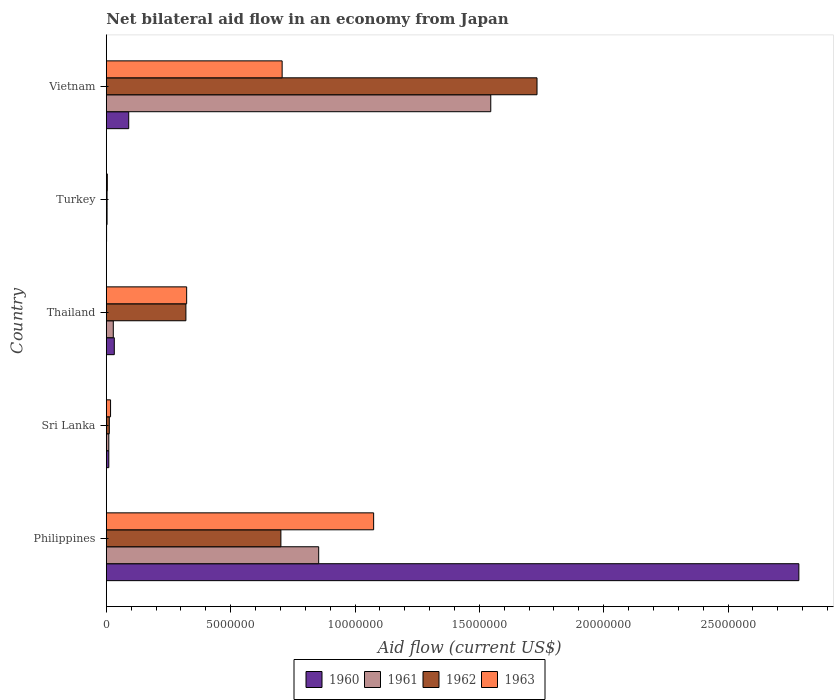How many different coloured bars are there?
Provide a succinct answer. 4. Are the number of bars per tick equal to the number of legend labels?
Your answer should be compact. Yes. Are the number of bars on each tick of the Y-axis equal?
Your response must be concise. Yes. How many bars are there on the 3rd tick from the top?
Ensure brevity in your answer.  4. How many bars are there on the 2nd tick from the bottom?
Make the answer very short. 4. What is the label of the 1st group of bars from the top?
Ensure brevity in your answer.  Vietnam. What is the net bilateral aid flow in 1963 in Turkey?
Make the answer very short. 4.00e+04. Across all countries, what is the maximum net bilateral aid flow in 1960?
Your response must be concise. 2.78e+07. What is the total net bilateral aid flow in 1963 in the graph?
Provide a short and direct response. 2.13e+07. What is the difference between the net bilateral aid flow in 1960 in Philippines and that in Thailand?
Offer a terse response. 2.75e+07. What is the difference between the net bilateral aid flow in 1963 in Vietnam and the net bilateral aid flow in 1960 in Philippines?
Offer a terse response. -2.08e+07. What is the average net bilateral aid flow in 1961 per country?
Provide a short and direct response. 4.88e+06. In how many countries, is the net bilateral aid flow in 1961 greater than 20000000 US$?
Make the answer very short. 0. What is the ratio of the net bilateral aid flow in 1960 in Philippines to that in Vietnam?
Ensure brevity in your answer.  30.94. Is the net bilateral aid flow in 1961 in Philippines less than that in Vietnam?
Your response must be concise. Yes. What is the difference between the highest and the second highest net bilateral aid flow in 1962?
Offer a terse response. 1.03e+07. What is the difference between the highest and the lowest net bilateral aid flow in 1961?
Your answer should be very brief. 1.54e+07. In how many countries, is the net bilateral aid flow in 1962 greater than the average net bilateral aid flow in 1962 taken over all countries?
Make the answer very short. 2. Is the sum of the net bilateral aid flow in 1962 in Thailand and Turkey greater than the maximum net bilateral aid flow in 1963 across all countries?
Give a very brief answer. No. Is it the case that in every country, the sum of the net bilateral aid flow in 1963 and net bilateral aid flow in 1960 is greater than the sum of net bilateral aid flow in 1962 and net bilateral aid flow in 1961?
Your answer should be compact. No. What does the 2nd bar from the top in Philippines represents?
Provide a succinct answer. 1962. Is it the case that in every country, the sum of the net bilateral aid flow in 1963 and net bilateral aid flow in 1961 is greater than the net bilateral aid flow in 1960?
Your response must be concise. No. How many bars are there?
Ensure brevity in your answer.  20. What is the difference between two consecutive major ticks on the X-axis?
Offer a terse response. 5.00e+06. Does the graph contain grids?
Your answer should be very brief. No. Where does the legend appear in the graph?
Ensure brevity in your answer.  Bottom center. What is the title of the graph?
Ensure brevity in your answer.  Net bilateral aid flow in an economy from Japan. Does "2007" appear as one of the legend labels in the graph?
Provide a short and direct response. No. What is the label or title of the X-axis?
Your response must be concise. Aid flow (current US$). What is the Aid flow (current US$) in 1960 in Philippines?
Offer a terse response. 2.78e+07. What is the Aid flow (current US$) of 1961 in Philippines?
Make the answer very short. 8.54e+06. What is the Aid flow (current US$) of 1962 in Philippines?
Offer a very short reply. 7.02e+06. What is the Aid flow (current US$) in 1963 in Philippines?
Give a very brief answer. 1.08e+07. What is the Aid flow (current US$) of 1961 in Sri Lanka?
Provide a short and direct response. 1.00e+05. What is the Aid flow (current US$) of 1962 in Sri Lanka?
Provide a short and direct response. 1.20e+05. What is the Aid flow (current US$) of 1963 in Sri Lanka?
Make the answer very short. 1.70e+05. What is the Aid flow (current US$) in 1962 in Thailand?
Your answer should be compact. 3.20e+06. What is the Aid flow (current US$) in 1963 in Thailand?
Provide a succinct answer. 3.23e+06. What is the Aid flow (current US$) in 1962 in Turkey?
Your answer should be compact. 3.00e+04. What is the Aid flow (current US$) of 1960 in Vietnam?
Provide a succinct answer. 9.00e+05. What is the Aid flow (current US$) of 1961 in Vietnam?
Ensure brevity in your answer.  1.55e+07. What is the Aid flow (current US$) of 1962 in Vietnam?
Your response must be concise. 1.73e+07. What is the Aid flow (current US$) of 1963 in Vietnam?
Offer a very short reply. 7.07e+06. Across all countries, what is the maximum Aid flow (current US$) of 1960?
Ensure brevity in your answer.  2.78e+07. Across all countries, what is the maximum Aid flow (current US$) in 1961?
Offer a terse response. 1.55e+07. Across all countries, what is the maximum Aid flow (current US$) in 1962?
Give a very brief answer. 1.73e+07. Across all countries, what is the maximum Aid flow (current US$) of 1963?
Offer a very short reply. 1.08e+07. Across all countries, what is the minimum Aid flow (current US$) of 1960?
Your response must be concise. 10000. Across all countries, what is the minimum Aid flow (current US$) in 1961?
Keep it short and to the point. 3.00e+04. Across all countries, what is the minimum Aid flow (current US$) of 1962?
Offer a terse response. 3.00e+04. Across all countries, what is the minimum Aid flow (current US$) in 1963?
Provide a short and direct response. 4.00e+04. What is the total Aid flow (current US$) in 1960 in the graph?
Make the answer very short. 2.92e+07. What is the total Aid flow (current US$) of 1961 in the graph?
Offer a very short reply. 2.44e+07. What is the total Aid flow (current US$) of 1962 in the graph?
Your answer should be compact. 2.77e+07. What is the total Aid flow (current US$) of 1963 in the graph?
Ensure brevity in your answer.  2.13e+07. What is the difference between the Aid flow (current US$) in 1960 in Philippines and that in Sri Lanka?
Your answer should be very brief. 2.78e+07. What is the difference between the Aid flow (current US$) in 1961 in Philippines and that in Sri Lanka?
Ensure brevity in your answer.  8.44e+06. What is the difference between the Aid flow (current US$) of 1962 in Philippines and that in Sri Lanka?
Keep it short and to the point. 6.90e+06. What is the difference between the Aid flow (current US$) of 1963 in Philippines and that in Sri Lanka?
Keep it short and to the point. 1.06e+07. What is the difference between the Aid flow (current US$) of 1960 in Philippines and that in Thailand?
Keep it short and to the point. 2.75e+07. What is the difference between the Aid flow (current US$) of 1961 in Philippines and that in Thailand?
Your answer should be compact. 8.26e+06. What is the difference between the Aid flow (current US$) of 1962 in Philippines and that in Thailand?
Keep it short and to the point. 3.82e+06. What is the difference between the Aid flow (current US$) of 1963 in Philippines and that in Thailand?
Offer a very short reply. 7.52e+06. What is the difference between the Aid flow (current US$) in 1960 in Philippines and that in Turkey?
Your answer should be compact. 2.78e+07. What is the difference between the Aid flow (current US$) of 1961 in Philippines and that in Turkey?
Your answer should be very brief. 8.51e+06. What is the difference between the Aid flow (current US$) in 1962 in Philippines and that in Turkey?
Offer a terse response. 6.99e+06. What is the difference between the Aid flow (current US$) of 1963 in Philippines and that in Turkey?
Give a very brief answer. 1.07e+07. What is the difference between the Aid flow (current US$) in 1960 in Philippines and that in Vietnam?
Provide a succinct answer. 2.70e+07. What is the difference between the Aid flow (current US$) of 1961 in Philippines and that in Vietnam?
Keep it short and to the point. -6.92e+06. What is the difference between the Aid flow (current US$) in 1962 in Philippines and that in Vietnam?
Make the answer very short. -1.03e+07. What is the difference between the Aid flow (current US$) of 1963 in Philippines and that in Vietnam?
Provide a short and direct response. 3.68e+06. What is the difference between the Aid flow (current US$) of 1961 in Sri Lanka and that in Thailand?
Your answer should be compact. -1.80e+05. What is the difference between the Aid flow (current US$) of 1962 in Sri Lanka and that in Thailand?
Offer a terse response. -3.08e+06. What is the difference between the Aid flow (current US$) in 1963 in Sri Lanka and that in Thailand?
Offer a very short reply. -3.06e+06. What is the difference between the Aid flow (current US$) in 1960 in Sri Lanka and that in Turkey?
Your answer should be compact. 9.00e+04. What is the difference between the Aid flow (current US$) of 1961 in Sri Lanka and that in Turkey?
Keep it short and to the point. 7.00e+04. What is the difference between the Aid flow (current US$) of 1962 in Sri Lanka and that in Turkey?
Make the answer very short. 9.00e+04. What is the difference between the Aid flow (current US$) of 1960 in Sri Lanka and that in Vietnam?
Your response must be concise. -8.00e+05. What is the difference between the Aid flow (current US$) of 1961 in Sri Lanka and that in Vietnam?
Your answer should be very brief. -1.54e+07. What is the difference between the Aid flow (current US$) in 1962 in Sri Lanka and that in Vietnam?
Ensure brevity in your answer.  -1.72e+07. What is the difference between the Aid flow (current US$) in 1963 in Sri Lanka and that in Vietnam?
Offer a very short reply. -6.90e+06. What is the difference between the Aid flow (current US$) of 1961 in Thailand and that in Turkey?
Keep it short and to the point. 2.50e+05. What is the difference between the Aid flow (current US$) of 1962 in Thailand and that in Turkey?
Offer a very short reply. 3.17e+06. What is the difference between the Aid flow (current US$) in 1963 in Thailand and that in Turkey?
Provide a short and direct response. 3.19e+06. What is the difference between the Aid flow (current US$) of 1960 in Thailand and that in Vietnam?
Offer a very short reply. -5.80e+05. What is the difference between the Aid flow (current US$) in 1961 in Thailand and that in Vietnam?
Your response must be concise. -1.52e+07. What is the difference between the Aid flow (current US$) in 1962 in Thailand and that in Vietnam?
Make the answer very short. -1.41e+07. What is the difference between the Aid flow (current US$) of 1963 in Thailand and that in Vietnam?
Your response must be concise. -3.84e+06. What is the difference between the Aid flow (current US$) in 1960 in Turkey and that in Vietnam?
Your answer should be compact. -8.90e+05. What is the difference between the Aid flow (current US$) in 1961 in Turkey and that in Vietnam?
Your answer should be compact. -1.54e+07. What is the difference between the Aid flow (current US$) of 1962 in Turkey and that in Vietnam?
Your answer should be very brief. -1.73e+07. What is the difference between the Aid flow (current US$) in 1963 in Turkey and that in Vietnam?
Offer a very short reply. -7.03e+06. What is the difference between the Aid flow (current US$) in 1960 in Philippines and the Aid flow (current US$) in 1961 in Sri Lanka?
Make the answer very short. 2.78e+07. What is the difference between the Aid flow (current US$) of 1960 in Philippines and the Aid flow (current US$) of 1962 in Sri Lanka?
Ensure brevity in your answer.  2.77e+07. What is the difference between the Aid flow (current US$) in 1960 in Philippines and the Aid flow (current US$) in 1963 in Sri Lanka?
Your answer should be compact. 2.77e+07. What is the difference between the Aid flow (current US$) of 1961 in Philippines and the Aid flow (current US$) of 1962 in Sri Lanka?
Give a very brief answer. 8.42e+06. What is the difference between the Aid flow (current US$) of 1961 in Philippines and the Aid flow (current US$) of 1963 in Sri Lanka?
Offer a very short reply. 8.37e+06. What is the difference between the Aid flow (current US$) of 1962 in Philippines and the Aid flow (current US$) of 1963 in Sri Lanka?
Provide a succinct answer. 6.85e+06. What is the difference between the Aid flow (current US$) of 1960 in Philippines and the Aid flow (current US$) of 1961 in Thailand?
Keep it short and to the point. 2.76e+07. What is the difference between the Aid flow (current US$) in 1960 in Philippines and the Aid flow (current US$) in 1962 in Thailand?
Provide a succinct answer. 2.46e+07. What is the difference between the Aid flow (current US$) of 1960 in Philippines and the Aid flow (current US$) of 1963 in Thailand?
Provide a succinct answer. 2.46e+07. What is the difference between the Aid flow (current US$) in 1961 in Philippines and the Aid flow (current US$) in 1962 in Thailand?
Your response must be concise. 5.34e+06. What is the difference between the Aid flow (current US$) in 1961 in Philippines and the Aid flow (current US$) in 1963 in Thailand?
Ensure brevity in your answer.  5.31e+06. What is the difference between the Aid flow (current US$) of 1962 in Philippines and the Aid flow (current US$) of 1963 in Thailand?
Provide a short and direct response. 3.79e+06. What is the difference between the Aid flow (current US$) in 1960 in Philippines and the Aid flow (current US$) in 1961 in Turkey?
Make the answer very short. 2.78e+07. What is the difference between the Aid flow (current US$) in 1960 in Philippines and the Aid flow (current US$) in 1962 in Turkey?
Offer a terse response. 2.78e+07. What is the difference between the Aid flow (current US$) in 1960 in Philippines and the Aid flow (current US$) in 1963 in Turkey?
Your answer should be very brief. 2.78e+07. What is the difference between the Aid flow (current US$) in 1961 in Philippines and the Aid flow (current US$) in 1962 in Turkey?
Ensure brevity in your answer.  8.51e+06. What is the difference between the Aid flow (current US$) of 1961 in Philippines and the Aid flow (current US$) of 1963 in Turkey?
Offer a very short reply. 8.50e+06. What is the difference between the Aid flow (current US$) in 1962 in Philippines and the Aid flow (current US$) in 1963 in Turkey?
Make the answer very short. 6.98e+06. What is the difference between the Aid flow (current US$) of 1960 in Philippines and the Aid flow (current US$) of 1961 in Vietnam?
Provide a succinct answer. 1.24e+07. What is the difference between the Aid flow (current US$) in 1960 in Philippines and the Aid flow (current US$) in 1962 in Vietnam?
Provide a short and direct response. 1.05e+07. What is the difference between the Aid flow (current US$) in 1960 in Philippines and the Aid flow (current US$) in 1963 in Vietnam?
Make the answer very short. 2.08e+07. What is the difference between the Aid flow (current US$) in 1961 in Philippines and the Aid flow (current US$) in 1962 in Vietnam?
Offer a terse response. -8.78e+06. What is the difference between the Aid flow (current US$) of 1961 in Philippines and the Aid flow (current US$) of 1963 in Vietnam?
Your answer should be very brief. 1.47e+06. What is the difference between the Aid flow (current US$) in 1962 in Philippines and the Aid flow (current US$) in 1963 in Vietnam?
Give a very brief answer. -5.00e+04. What is the difference between the Aid flow (current US$) in 1960 in Sri Lanka and the Aid flow (current US$) in 1961 in Thailand?
Give a very brief answer. -1.80e+05. What is the difference between the Aid flow (current US$) in 1960 in Sri Lanka and the Aid flow (current US$) in 1962 in Thailand?
Offer a terse response. -3.10e+06. What is the difference between the Aid flow (current US$) of 1960 in Sri Lanka and the Aid flow (current US$) of 1963 in Thailand?
Provide a short and direct response. -3.13e+06. What is the difference between the Aid flow (current US$) in 1961 in Sri Lanka and the Aid flow (current US$) in 1962 in Thailand?
Make the answer very short. -3.10e+06. What is the difference between the Aid flow (current US$) in 1961 in Sri Lanka and the Aid flow (current US$) in 1963 in Thailand?
Your response must be concise. -3.13e+06. What is the difference between the Aid flow (current US$) in 1962 in Sri Lanka and the Aid flow (current US$) in 1963 in Thailand?
Offer a terse response. -3.11e+06. What is the difference between the Aid flow (current US$) of 1960 in Sri Lanka and the Aid flow (current US$) of 1961 in Turkey?
Provide a succinct answer. 7.00e+04. What is the difference between the Aid flow (current US$) of 1960 in Sri Lanka and the Aid flow (current US$) of 1962 in Turkey?
Offer a terse response. 7.00e+04. What is the difference between the Aid flow (current US$) of 1960 in Sri Lanka and the Aid flow (current US$) of 1963 in Turkey?
Your answer should be compact. 6.00e+04. What is the difference between the Aid flow (current US$) in 1961 in Sri Lanka and the Aid flow (current US$) in 1962 in Turkey?
Offer a very short reply. 7.00e+04. What is the difference between the Aid flow (current US$) in 1960 in Sri Lanka and the Aid flow (current US$) in 1961 in Vietnam?
Make the answer very short. -1.54e+07. What is the difference between the Aid flow (current US$) in 1960 in Sri Lanka and the Aid flow (current US$) in 1962 in Vietnam?
Offer a terse response. -1.72e+07. What is the difference between the Aid flow (current US$) of 1960 in Sri Lanka and the Aid flow (current US$) of 1963 in Vietnam?
Offer a terse response. -6.97e+06. What is the difference between the Aid flow (current US$) of 1961 in Sri Lanka and the Aid flow (current US$) of 1962 in Vietnam?
Your response must be concise. -1.72e+07. What is the difference between the Aid flow (current US$) of 1961 in Sri Lanka and the Aid flow (current US$) of 1963 in Vietnam?
Provide a succinct answer. -6.97e+06. What is the difference between the Aid flow (current US$) in 1962 in Sri Lanka and the Aid flow (current US$) in 1963 in Vietnam?
Ensure brevity in your answer.  -6.95e+06. What is the difference between the Aid flow (current US$) of 1960 in Thailand and the Aid flow (current US$) of 1961 in Turkey?
Provide a short and direct response. 2.90e+05. What is the difference between the Aid flow (current US$) of 1960 in Thailand and the Aid flow (current US$) of 1963 in Turkey?
Offer a very short reply. 2.80e+05. What is the difference between the Aid flow (current US$) in 1961 in Thailand and the Aid flow (current US$) in 1962 in Turkey?
Offer a terse response. 2.50e+05. What is the difference between the Aid flow (current US$) in 1961 in Thailand and the Aid flow (current US$) in 1963 in Turkey?
Your answer should be very brief. 2.40e+05. What is the difference between the Aid flow (current US$) in 1962 in Thailand and the Aid flow (current US$) in 1963 in Turkey?
Offer a very short reply. 3.16e+06. What is the difference between the Aid flow (current US$) of 1960 in Thailand and the Aid flow (current US$) of 1961 in Vietnam?
Your answer should be compact. -1.51e+07. What is the difference between the Aid flow (current US$) in 1960 in Thailand and the Aid flow (current US$) in 1962 in Vietnam?
Keep it short and to the point. -1.70e+07. What is the difference between the Aid flow (current US$) in 1960 in Thailand and the Aid flow (current US$) in 1963 in Vietnam?
Offer a terse response. -6.75e+06. What is the difference between the Aid flow (current US$) in 1961 in Thailand and the Aid flow (current US$) in 1962 in Vietnam?
Your answer should be compact. -1.70e+07. What is the difference between the Aid flow (current US$) in 1961 in Thailand and the Aid flow (current US$) in 1963 in Vietnam?
Offer a terse response. -6.79e+06. What is the difference between the Aid flow (current US$) in 1962 in Thailand and the Aid flow (current US$) in 1963 in Vietnam?
Offer a terse response. -3.87e+06. What is the difference between the Aid flow (current US$) in 1960 in Turkey and the Aid flow (current US$) in 1961 in Vietnam?
Your answer should be very brief. -1.54e+07. What is the difference between the Aid flow (current US$) in 1960 in Turkey and the Aid flow (current US$) in 1962 in Vietnam?
Provide a succinct answer. -1.73e+07. What is the difference between the Aid flow (current US$) in 1960 in Turkey and the Aid flow (current US$) in 1963 in Vietnam?
Offer a terse response. -7.06e+06. What is the difference between the Aid flow (current US$) in 1961 in Turkey and the Aid flow (current US$) in 1962 in Vietnam?
Ensure brevity in your answer.  -1.73e+07. What is the difference between the Aid flow (current US$) of 1961 in Turkey and the Aid flow (current US$) of 1963 in Vietnam?
Make the answer very short. -7.04e+06. What is the difference between the Aid flow (current US$) in 1962 in Turkey and the Aid flow (current US$) in 1963 in Vietnam?
Offer a terse response. -7.04e+06. What is the average Aid flow (current US$) in 1960 per country?
Offer a very short reply. 5.84e+06. What is the average Aid flow (current US$) of 1961 per country?
Provide a short and direct response. 4.88e+06. What is the average Aid flow (current US$) of 1962 per country?
Make the answer very short. 5.54e+06. What is the average Aid flow (current US$) in 1963 per country?
Give a very brief answer. 4.25e+06. What is the difference between the Aid flow (current US$) of 1960 and Aid flow (current US$) of 1961 in Philippines?
Offer a terse response. 1.93e+07. What is the difference between the Aid flow (current US$) of 1960 and Aid flow (current US$) of 1962 in Philippines?
Your response must be concise. 2.08e+07. What is the difference between the Aid flow (current US$) in 1960 and Aid flow (current US$) in 1963 in Philippines?
Give a very brief answer. 1.71e+07. What is the difference between the Aid flow (current US$) of 1961 and Aid flow (current US$) of 1962 in Philippines?
Keep it short and to the point. 1.52e+06. What is the difference between the Aid flow (current US$) in 1961 and Aid flow (current US$) in 1963 in Philippines?
Your answer should be compact. -2.21e+06. What is the difference between the Aid flow (current US$) of 1962 and Aid flow (current US$) of 1963 in Philippines?
Offer a very short reply. -3.73e+06. What is the difference between the Aid flow (current US$) of 1960 and Aid flow (current US$) of 1962 in Sri Lanka?
Ensure brevity in your answer.  -2.00e+04. What is the difference between the Aid flow (current US$) in 1961 and Aid flow (current US$) in 1962 in Sri Lanka?
Ensure brevity in your answer.  -2.00e+04. What is the difference between the Aid flow (current US$) in 1961 and Aid flow (current US$) in 1963 in Sri Lanka?
Offer a terse response. -7.00e+04. What is the difference between the Aid flow (current US$) in 1960 and Aid flow (current US$) in 1961 in Thailand?
Keep it short and to the point. 4.00e+04. What is the difference between the Aid flow (current US$) in 1960 and Aid flow (current US$) in 1962 in Thailand?
Ensure brevity in your answer.  -2.88e+06. What is the difference between the Aid flow (current US$) of 1960 and Aid flow (current US$) of 1963 in Thailand?
Give a very brief answer. -2.91e+06. What is the difference between the Aid flow (current US$) of 1961 and Aid flow (current US$) of 1962 in Thailand?
Keep it short and to the point. -2.92e+06. What is the difference between the Aid flow (current US$) of 1961 and Aid flow (current US$) of 1963 in Thailand?
Provide a short and direct response. -2.95e+06. What is the difference between the Aid flow (current US$) in 1960 and Aid flow (current US$) in 1961 in Turkey?
Your answer should be very brief. -2.00e+04. What is the difference between the Aid flow (current US$) of 1960 and Aid flow (current US$) of 1962 in Turkey?
Ensure brevity in your answer.  -2.00e+04. What is the difference between the Aid flow (current US$) in 1961 and Aid flow (current US$) in 1963 in Turkey?
Your response must be concise. -10000. What is the difference between the Aid flow (current US$) of 1962 and Aid flow (current US$) of 1963 in Turkey?
Give a very brief answer. -10000. What is the difference between the Aid flow (current US$) of 1960 and Aid flow (current US$) of 1961 in Vietnam?
Make the answer very short. -1.46e+07. What is the difference between the Aid flow (current US$) in 1960 and Aid flow (current US$) in 1962 in Vietnam?
Make the answer very short. -1.64e+07. What is the difference between the Aid flow (current US$) in 1960 and Aid flow (current US$) in 1963 in Vietnam?
Make the answer very short. -6.17e+06. What is the difference between the Aid flow (current US$) of 1961 and Aid flow (current US$) of 1962 in Vietnam?
Provide a short and direct response. -1.86e+06. What is the difference between the Aid flow (current US$) in 1961 and Aid flow (current US$) in 1963 in Vietnam?
Offer a terse response. 8.39e+06. What is the difference between the Aid flow (current US$) in 1962 and Aid flow (current US$) in 1963 in Vietnam?
Provide a short and direct response. 1.02e+07. What is the ratio of the Aid flow (current US$) in 1960 in Philippines to that in Sri Lanka?
Offer a very short reply. 278.5. What is the ratio of the Aid flow (current US$) of 1961 in Philippines to that in Sri Lanka?
Your answer should be very brief. 85.4. What is the ratio of the Aid flow (current US$) in 1962 in Philippines to that in Sri Lanka?
Ensure brevity in your answer.  58.5. What is the ratio of the Aid flow (current US$) in 1963 in Philippines to that in Sri Lanka?
Offer a terse response. 63.24. What is the ratio of the Aid flow (current US$) in 1960 in Philippines to that in Thailand?
Offer a very short reply. 87.03. What is the ratio of the Aid flow (current US$) in 1961 in Philippines to that in Thailand?
Ensure brevity in your answer.  30.5. What is the ratio of the Aid flow (current US$) in 1962 in Philippines to that in Thailand?
Offer a very short reply. 2.19. What is the ratio of the Aid flow (current US$) of 1963 in Philippines to that in Thailand?
Ensure brevity in your answer.  3.33. What is the ratio of the Aid flow (current US$) of 1960 in Philippines to that in Turkey?
Provide a succinct answer. 2785. What is the ratio of the Aid flow (current US$) of 1961 in Philippines to that in Turkey?
Your answer should be compact. 284.67. What is the ratio of the Aid flow (current US$) in 1962 in Philippines to that in Turkey?
Ensure brevity in your answer.  234. What is the ratio of the Aid flow (current US$) of 1963 in Philippines to that in Turkey?
Offer a terse response. 268.75. What is the ratio of the Aid flow (current US$) in 1960 in Philippines to that in Vietnam?
Offer a terse response. 30.94. What is the ratio of the Aid flow (current US$) in 1961 in Philippines to that in Vietnam?
Your answer should be very brief. 0.55. What is the ratio of the Aid flow (current US$) of 1962 in Philippines to that in Vietnam?
Your answer should be compact. 0.41. What is the ratio of the Aid flow (current US$) in 1963 in Philippines to that in Vietnam?
Provide a succinct answer. 1.52. What is the ratio of the Aid flow (current US$) in 1960 in Sri Lanka to that in Thailand?
Make the answer very short. 0.31. What is the ratio of the Aid flow (current US$) in 1961 in Sri Lanka to that in Thailand?
Offer a very short reply. 0.36. What is the ratio of the Aid flow (current US$) of 1962 in Sri Lanka to that in Thailand?
Ensure brevity in your answer.  0.04. What is the ratio of the Aid flow (current US$) of 1963 in Sri Lanka to that in Thailand?
Make the answer very short. 0.05. What is the ratio of the Aid flow (current US$) of 1963 in Sri Lanka to that in Turkey?
Offer a very short reply. 4.25. What is the ratio of the Aid flow (current US$) in 1960 in Sri Lanka to that in Vietnam?
Offer a terse response. 0.11. What is the ratio of the Aid flow (current US$) in 1961 in Sri Lanka to that in Vietnam?
Give a very brief answer. 0.01. What is the ratio of the Aid flow (current US$) of 1962 in Sri Lanka to that in Vietnam?
Your response must be concise. 0.01. What is the ratio of the Aid flow (current US$) in 1963 in Sri Lanka to that in Vietnam?
Your answer should be very brief. 0.02. What is the ratio of the Aid flow (current US$) in 1960 in Thailand to that in Turkey?
Offer a terse response. 32. What is the ratio of the Aid flow (current US$) of 1961 in Thailand to that in Turkey?
Your answer should be compact. 9.33. What is the ratio of the Aid flow (current US$) of 1962 in Thailand to that in Turkey?
Give a very brief answer. 106.67. What is the ratio of the Aid flow (current US$) in 1963 in Thailand to that in Turkey?
Your answer should be very brief. 80.75. What is the ratio of the Aid flow (current US$) of 1960 in Thailand to that in Vietnam?
Your response must be concise. 0.36. What is the ratio of the Aid flow (current US$) of 1961 in Thailand to that in Vietnam?
Offer a terse response. 0.02. What is the ratio of the Aid flow (current US$) of 1962 in Thailand to that in Vietnam?
Your answer should be very brief. 0.18. What is the ratio of the Aid flow (current US$) of 1963 in Thailand to that in Vietnam?
Make the answer very short. 0.46. What is the ratio of the Aid flow (current US$) in 1960 in Turkey to that in Vietnam?
Your answer should be compact. 0.01. What is the ratio of the Aid flow (current US$) in 1961 in Turkey to that in Vietnam?
Your response must be concise. 0. What is the ratio of the Aid flow (current US$) of 1962 in Turkey to that in Vietnam?
Keep it short and to the point. 0. What is the ratio of the Aid flow (current US$) of 1963 in Turkey to that in Vietnam?
Make the answer very short. 0.01. What is the difference between the highest and the second highest Aid flow (current US$) of 1960?
Make the answer very short. 2.70e+07. What is the difference between the highest and the second highest Aid flow (current US$) of 1961?
Your response must be concise. 6.92e+06. What is the difference between the highest and the second highest Aid flow (current US$) in 1962?
Your answer should be very brief. 1.03e+07. What is the difference between the highest and the second highest Aid flow (current US$) in 1963?
Your response must be concise. 3.68e+06. What is the difference between the highest and the lowest Aid flow (current US$) in 1960?
Ensure brevity in your answer.  2.78e+07. What is the difference between the highest and the lowest Aid flow (current US$) of 1961?
Your response must be concise. 1.54e+07. What is the difference between the highest and the lowest Aid flow (current US$) of 1962?
Make the answer very short. 1.73e+07. What is the difference between the highest and the lowest Aid flow (current US$) of 1963?
Your response must be concise. 1.07e+07. 